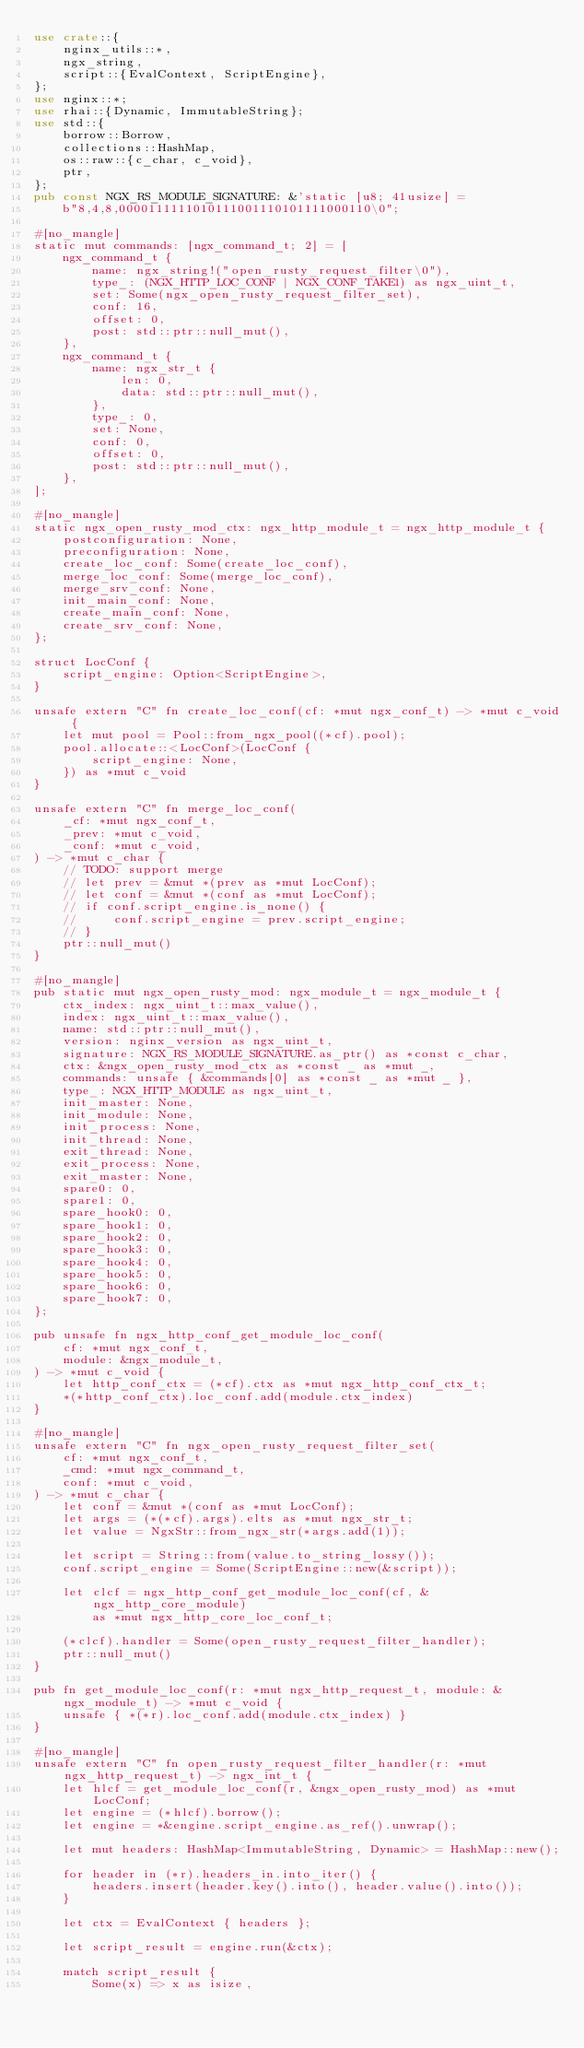<code> <loc_0><loc_0><loc_500><loc_500><_Rust_>use crate::{
    nginx_utils::*,
    ngx_string,
    script::{EvalContext, ScriptEngine},
};
use nginx::*;
use rhai::{Dynamic, ImmutableString};
use std::{
    borrow::Borrow,
    collections::HashMap,
    os::raw::{c_char, c_void},
    ptr,
};
pub const NGX_RS_MODULE_SIGNATURE: &'static [u8; 41usize] =
    b"8,4,8,0000111111010111001110101111000110\0";

#[no_mangle]
static mut commands: [ngx_command_t; 2] = [
    ngx_command_t {
        name: ngx_string!("open_rusty_request_filter\0"),
        type_: (NGX_HTTP_LOC_CONF | NGX_CONF_TAKE1) as ngx_uint_t,
        set: Some(ngx_open_rusty_request_filter_set),
        conf: 16,
        offset: 0,
        post: std::ptr::null_mut(),
    },
    ngx_command_t {
        name: ngx_str_t {
            len: 0,
            data: std::ptr::null_mut(),
        },
        type_: 0,
        set: None,
        conf: 0,
        offset: 0,
        post: std::ptr::null_mut(),
    },
];

#[no_mangle]
static ngx_open_rusty_mod_ctx: ngx_http_module_t = ngx_http_module_t {
    postconfiguration: None,
    preconfiguration: None,
    create_loc_conf: Some(create_loc_conf),
    merge_loc_conf: Some(merge_loc_conf),
    merge_srv_conf: None,
    init_main_conf: None,
    create_main_conf: None,
    create_srv_conf: None,
};

struct LocConf {
    script_engine: Option<ScriptEngine>,
}

unsafe extern "C" fn create_loc_conf(cf: *mut ngx_conf_t) -> *mut c_void {
    let mut pool = Pool::from_ngx_pool((*cf).pool);
    pool.allocate::<LocConf>(LocConf {
        script_engine: None,
    }) as *mut c_void
}

unsafe extern "C" fn merge_loc_conf(
    _cf: *mut ngx_conf_t,
    _prev: *mut c_void,
    _conf: *mut c_void,
) -> *mut c_char {
    // TODO: support merge
    // let prev = &mut *(prev as *mut LocConf);
    // let conf = &mut *(conf as *mut LocConf);
    // if conf.script_engine.is_none() {
    //     conf.script_engine = prev.script_engine;
    // }
    ptr::null_mut()
}

#[no_mangle]
pub static mut ngx_open_rusty_mod: ngx_module_t = ngx_module_t {
    ctx_index: ngx_uint_t::max_value(),
    index: ngx_uint_t::max_value(),
    name: std::ptr::null_mut(),
    version: nginx_version as ngx_uint_t,
    signature: NGX_RS_MODULE_SIGNATURE.as_ptr() as *const c_char,
    ctx: &ngx_open_rusty_mod_ctx as *const _ as *mut _,
    commands: unsafe { &commands[0] as *const _ as *mut _ },
    type_: NGX_HTTP_MODULE as ngx_uint_t,
    init_master: None,
    init_module: None,
    init_process: None,
    init_thread: None,
    exit_thread: None,
    exit_process: None,
    exit_master: None,
    spare0: 0,
    spare1: 0,
    spare_hook0: 0,
    spare_hook1: 0,
    spare_hook2: 0,
    spare_hook3: 0,
    spare_hook4: 0,
    spare_hook5: 0,
    spare_hook6: 0,
    spare_hook7: 0,
};

pub unsafe fn ngx_http_conf_get_module_loc_conf(
    cf: *mut ngx_conf_t,
    module: &ngx_module_t,
) -> *mut c_void {
    let http_conf_ctx = (*cf).ctx as *mut ngx_http_conf_ctx_t;
    *(*http_conf_ctx).loc_conf.add(module.ctx_index)
}

#[no_mangle]
unsafe extern "C" fn ngx_open_rusty_request_filter_set(
    cf: *mut ngx_conf_t,
    _cmd: *mut ngx_command_t,
    conf: *mut c_void,
) -> *mut c_char {
    let conf = &mut *(conf as *mut LocConf);
    let args = (*(*cf).args).elts as *mut ngx_str_t;
    let value = NgxStr::from_ngx_str(*args.add(1));

    let script = String::from(value.to_string_lossy());
    conf.script_engine = Some(ScriptEngine::new(&script));

    let clcf = ngx_http_conf_get_module_loc_conf(cf, &ngx_http_core_module)
        as *mut ngx_http_core_loc_conf_t;

    (*clcf).handler = Some(open_rusty_request_filter_handler);
    ptr::null_mut()
}

pub fn get_module_loc_conf(r: *mut ngx_http_request_t, module: &ngx_module_t) -> *mut c_void {
    unsafe { *(*r).loc_conf.add(module.ctx_index) }
}

#[no_mangle]
unsafe extern "C" fn open_rusty_request_filter_handler(r: *mut ngx_http_request_t) -> ngx_int_t {
    let hlcf = get_module_loc_conf(r, &ngx_open_rusty_mod) as *mut LocConf;
    let engine = (*hlcf).borrow();
    let engine = *&engine.script_engine.as_ref().unwrap();

    let mut headers: HashMap<ImmutableString, Dynamic> = HashMap::new();

    for header in (*r).headers_in.into_iter() {
        headers.insert(header.key().into(), header.value().into());
    }

    let ctx = EvalContext { headers };

    let script_result = engine.run(&ctx);

    match script_result {
        Some(x) => x as isize,</code> 